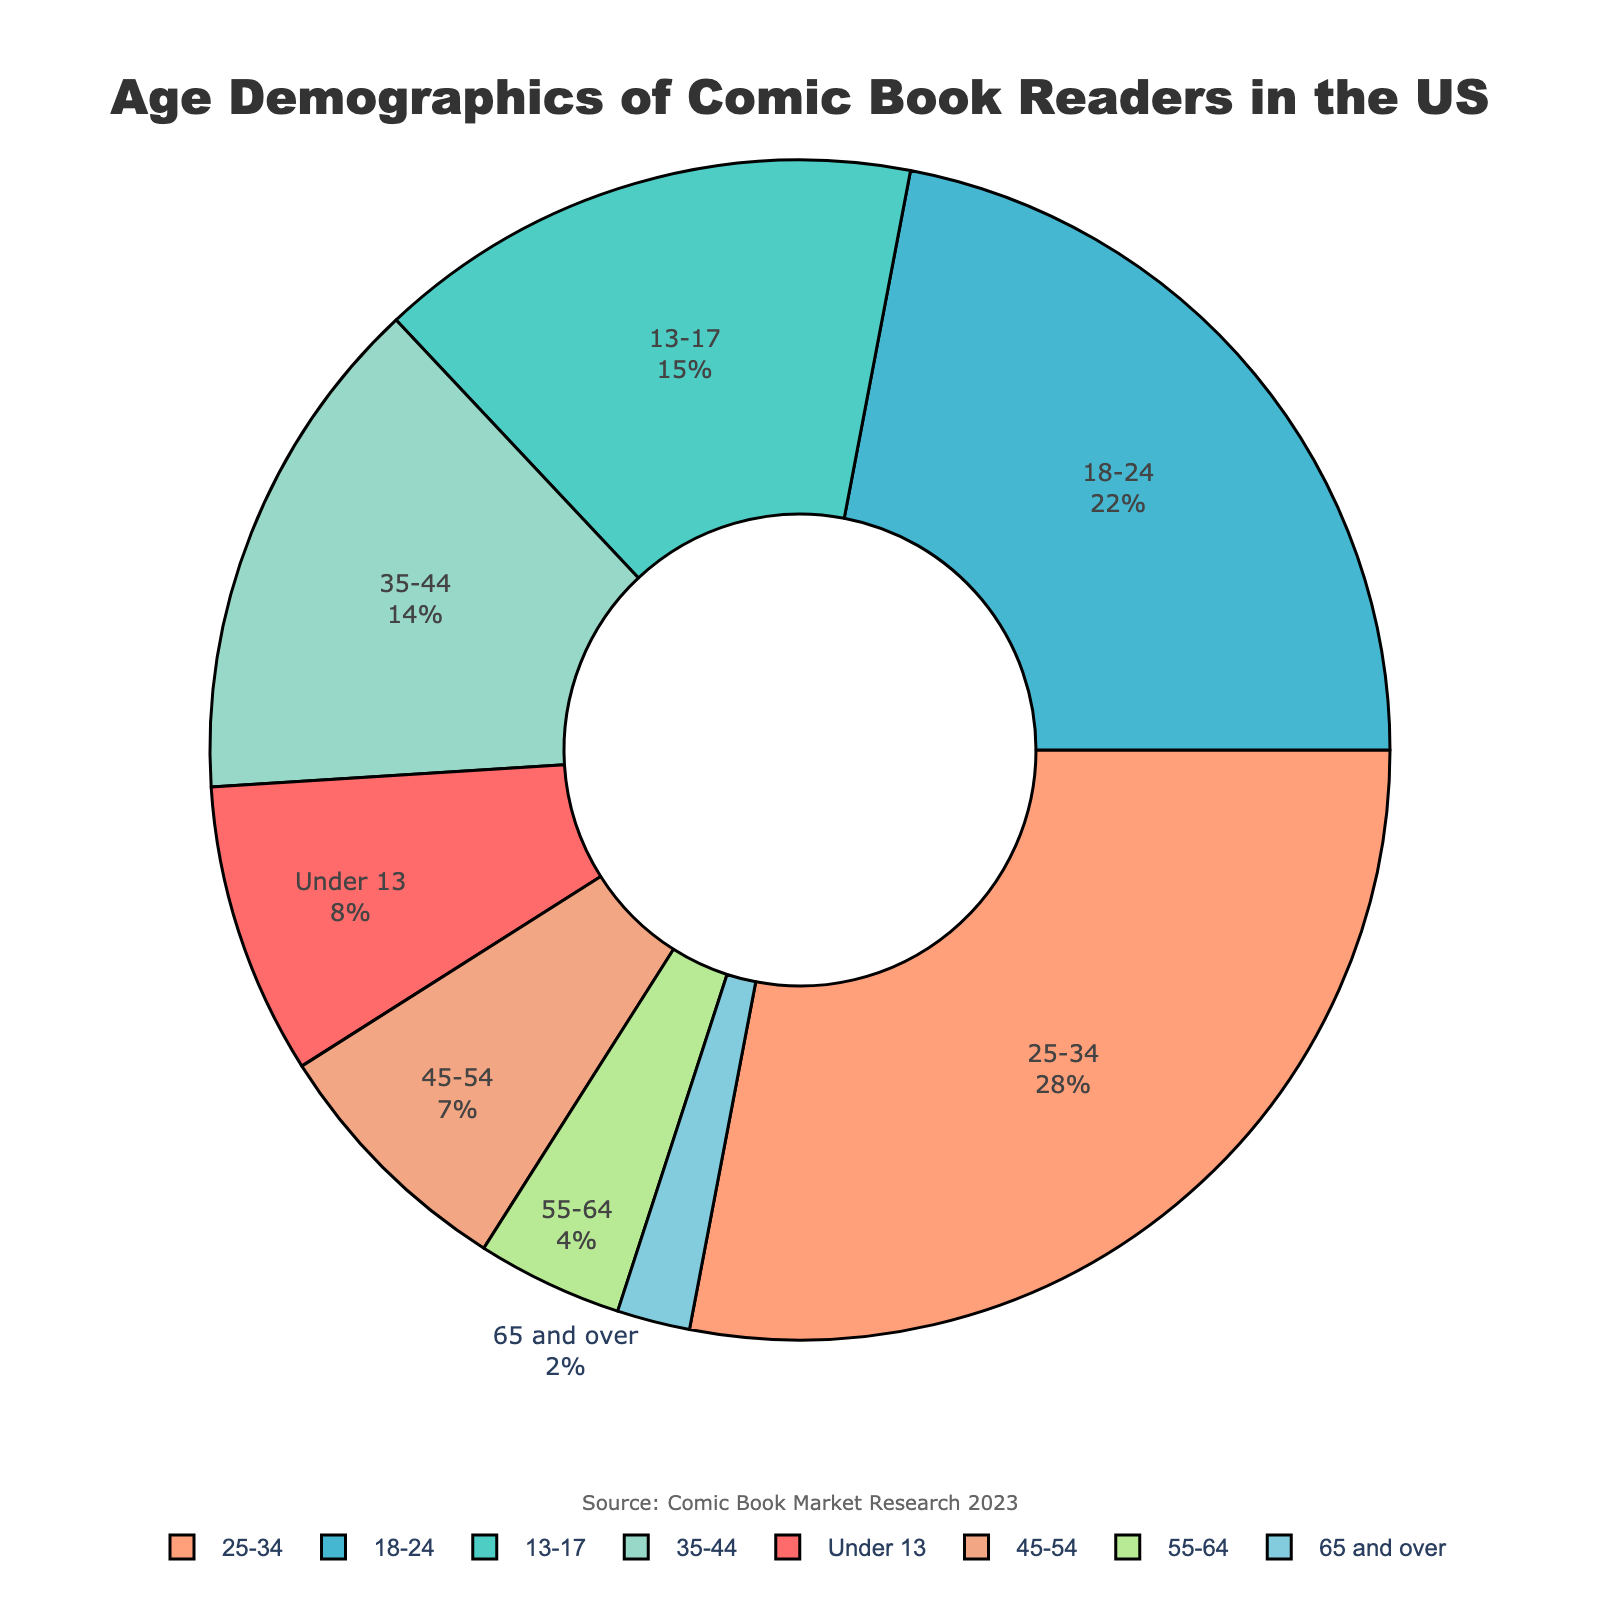Which age range has the largest percentage of comic book readers? The pie chart shows different age ranges with their respective percentages. By looking at the segment sizes, the largest percentage corresponds to the 25-34 age range.
Answer: 25-34 What is the total percentage of comic book readers under 18? To find the total percentage, sum the percentages of the age ranges under 18 which are "Under 13" and "13-17". That is 8% + 15% = 23%.
Answer: 23% How does the percentage of comic book readers aged 18-24 compare to those aged 35-44? From the pie chart, the percentage for the 18-24 age range is 22%, and for the 35-44 age range is 14%. To compare, 22% is greater than 14%.
Answer: 18-24 has higher percentage What's the combined percentage of comic book readers aged 45 and older? Sum the percentages of the age ranges "45-54", "55-64", and "65 and over". That is 7% + 4% + 2% = 13%.
Answer: 13% Which segment in the pie chart is visually represented with a red color? The pie chart uses specific colors for the segments. The red color corresponds to the age range "Under 13".
Answer: Under 13 What is the difference in the percentage of comic book readers between the 18-24 and the 13-17 age groups? The percentage for the 18-24 age range is 22%, and for the 13-17 age range is 15%. The difference is 22% - 15% = 7%.
Answer: 7% What is the median percentage value of the age ranges presented in the pie chart? First, list the percentage values in ascending order: 2, 4, 7, 8, 14, 15, 22, 28. With 8 values, the median will be the average of the 4th and 5th values: (8 + 14) / 2 = 11%.
Answer: 11% Which age group constitutes less than 5% of the total comic book readers? By examining the pie chart, the age groups "55-64" with 4% and "65 and over" with 2% both constitute less than 5% of the total comic book readers.
Answer: 55-64 and 65 and over What is the smallest age group represented in the pie chart? By examining the percentages, the smallest age group is "65 and over" with 2%.
Answer: 65 and over What percentage of comic book readers are aged 25-54? Sum the percentages for the age ranges "25-34", "35-44", and "45-54". That is 28% + 14% + 7% = 49%.
Answer: 49% 